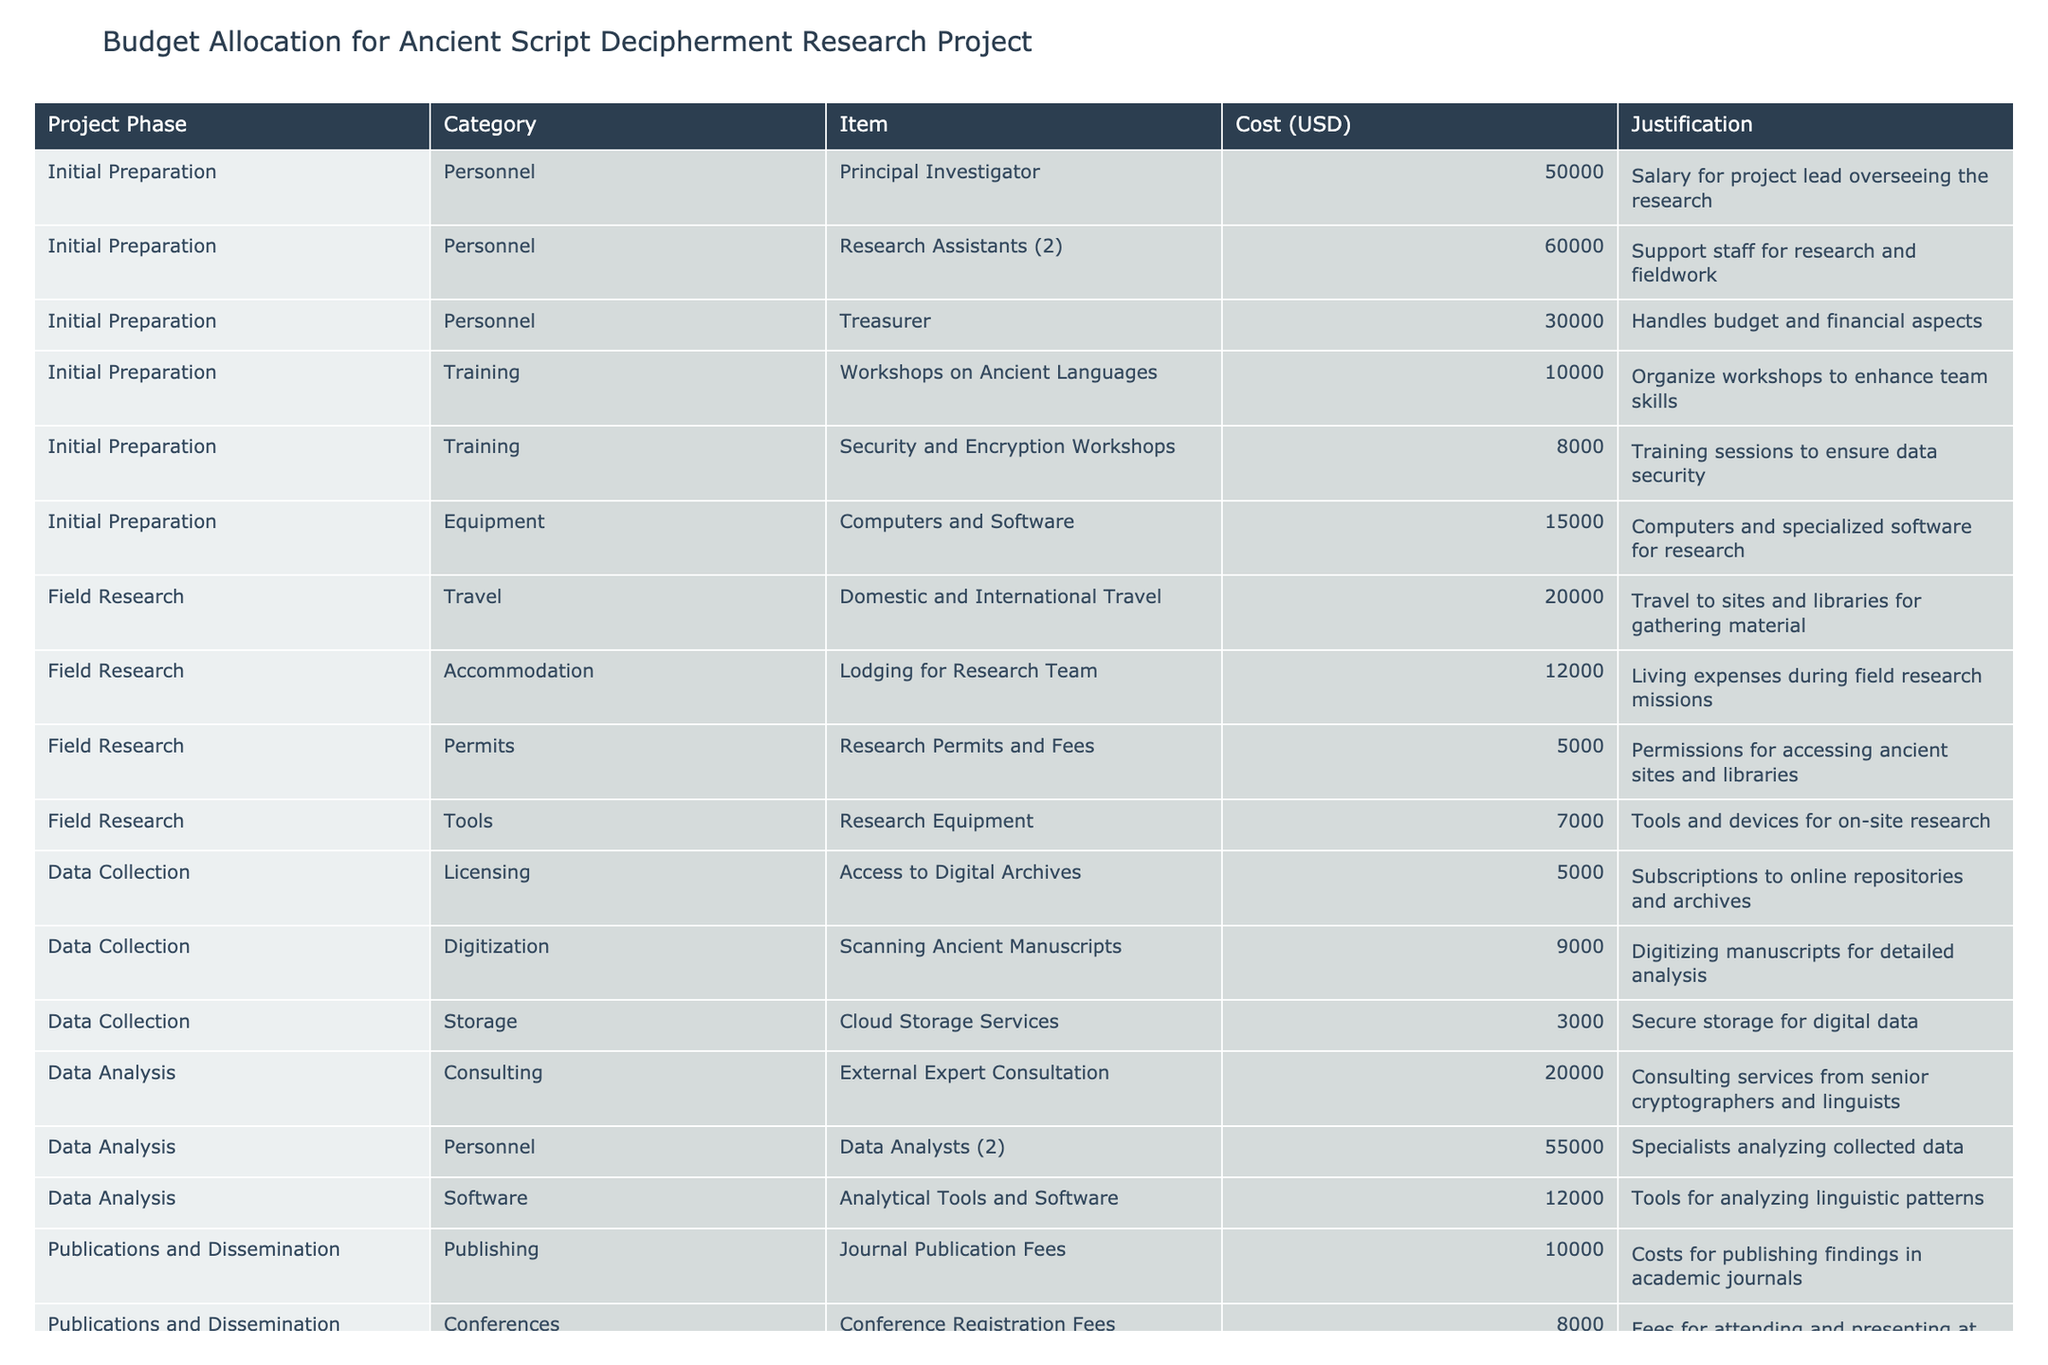What is the total budget allocated for personnel? Adding the costs of personnel categories includes Principal Investigator (50000), Research Assistants (60000), and Treasurer (30000). Thus, the total is 50000 + 60000 + 30000 = 140000 USD.
Answer: 140000 USD How much money is allocated for training workshops? The allocated funds for training workshops include Workshops on Ancient Languages (10000) and Security and Encryption Workshops (8000). Therefore, the total is 10000 + 8000 = 18000 USD.
Answer: 18000 USD Is the cost of domestic and international travel higher than the total spending on tools for field research? The cost for domestic and international travel is 20000 USD. The spending on tools for field research (Research Equipment) is 7000 USD. Since 20000 is greater than 7000, the statement is true.
Answer: Yes What is the cost difference between publishing and marketing activities? The costs are Journal Publication Fees (10000) and Promotional Materials (5000). The difference is 10000 - 5000 = 5000 USD.
Answer: 5000 USD How many categories have more than one item listed in the budget? Categories like Personnel (3 items), Training (2 items), and Data Analysis (3 items) all have multiple items, tallying to 3 categories in total.
Answer: 3 categories What percentage of the total budget is accounted for by data analysis expenses? The total budget is 414000 USD. The data analysis expenses are External Expert Consultation (20000), Data Analysts (55000), and Analytical Tools and Software (12000), which sum up to 20000 + 55000 + 12000 = 87000 USD. The percentage is (87000 / 414000) * 100 ≈ 21.0%.
Answer: 21.0% What are the total costs for publications and dissemination? The costs include Journal Publication Fees (10000), Conference Registration Fees (8000), Marketing (5000), and Workshops for Educational Outreach (7000), which adds up to 10000 + 8000 + 5000 + 7000 = 32000 USD.
Answer: 32000 USD Which phase has the highest expense item and what is that item? In the table, the phase with the highest expense item is Data Analysis, specifically the Data Analysts (2) with a cost of 55000 USD.
Answer: Data Analysts (2), 55000 USD 